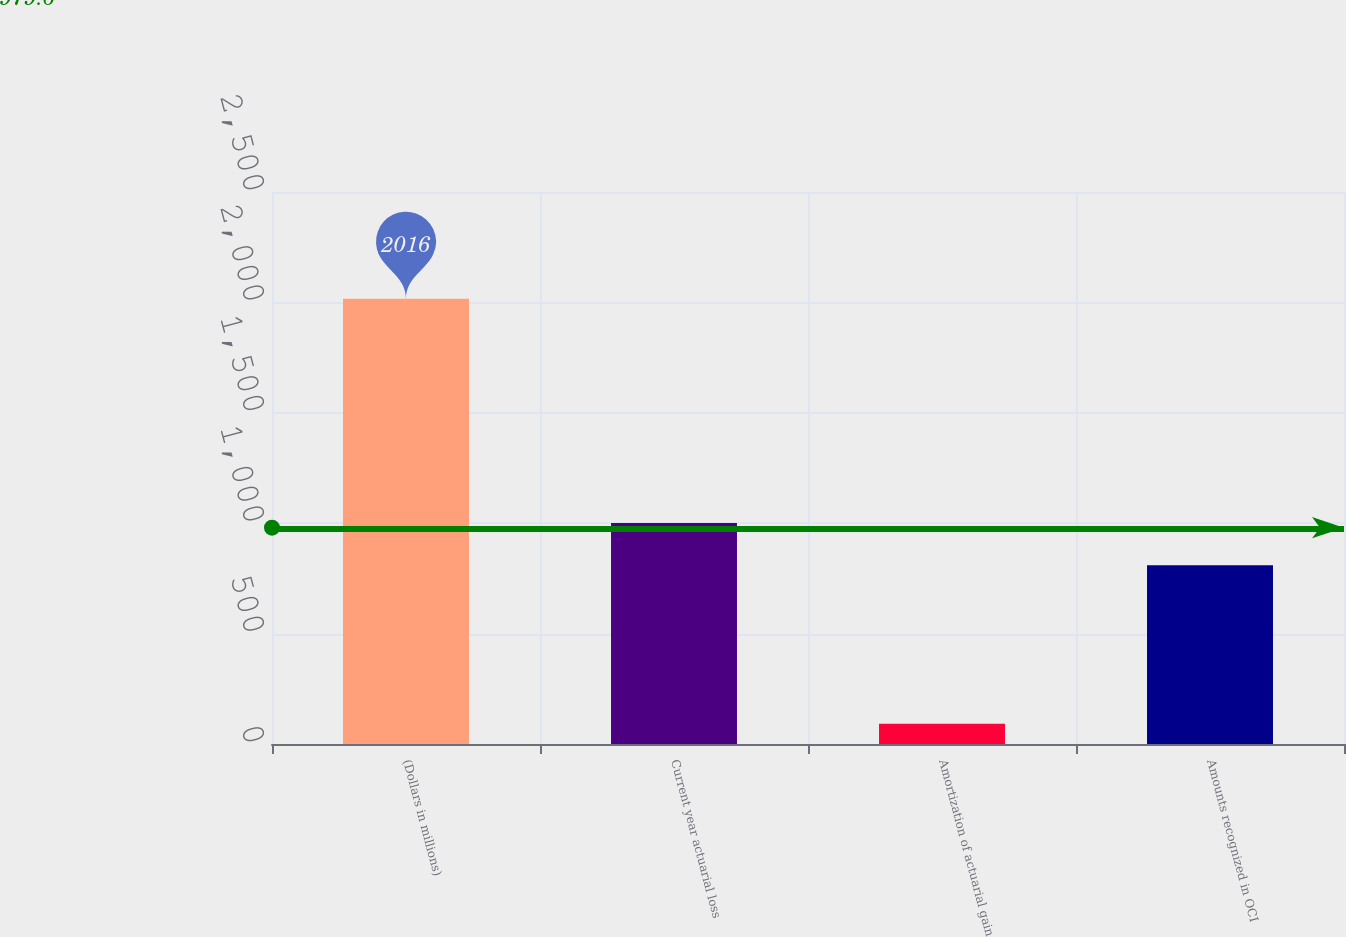Convert chart to OTSL. <chart><loc_0><loc_0><loc_500><loc_500><bar_chart><fcel>(Dollars in millions)<fcel>Current year actuarial loss<fcel>Amortization of actuarial gain<fcel>Amounts recognized in OCI<nl><fcel>2016<fcel>1001.4<fcel>92<fcel>809<nl></chart> 